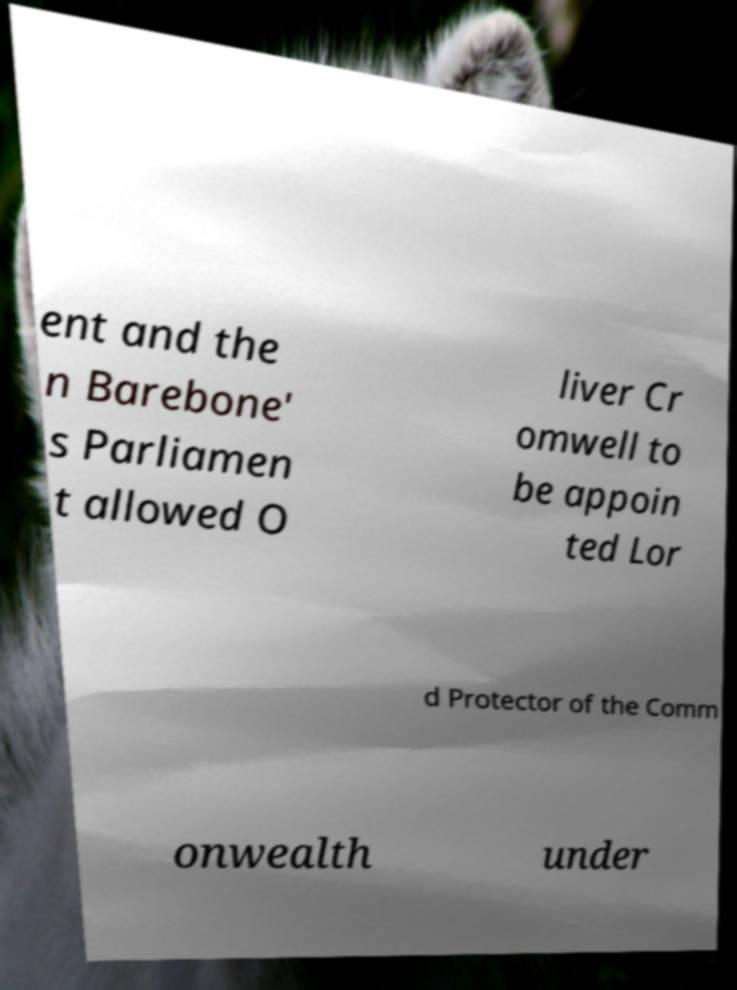Could you assist in decoding the text presented in this image and type it out clearly? ent and the n Barebone' s Parliamen t allowed O liver Cr omwell to be appoin ted Lor d Protector of the Comm onwealth under 